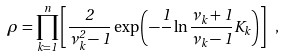<formula> <loc_0><loc_0><loc_500><loc_500>\rho = \prod _ { k = 1 } ^ { n } \left [ \frac { 2 } { \nu _ { k } ^ { 2 } - 1 } \exp \left ( - \frac { 1 } { } \ln \frac { \nu _ { k } + 1 } { \nu _ { k } - 1 } K _ { k } \right ) \right ] \ ,</formula> 